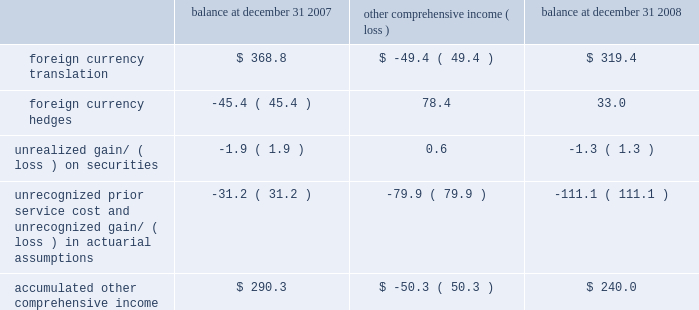The years ended december 31 , 2008 , 2007 and 2006 , due to ineffectiveness and amounts excluded from the assessment of hedge effectiveness , was not significant .
For contracts outstanding at december 31 , 2008 , we have an obligation to purchase u.s .
Dollars and sell euros , japanese yen , british pounds , canadian dollars , australian dollars and korean won and purchase swiss francs and sell u.s .
Dollars at set maturity dates ranging from january 2009 through june 2011 .
The notional amounts of outstanding forward contracts entered into with third parties to purchase u.s .
Dollars at december 31 , 2008 were $ 1343.0 million .
The notional amounts of outstanding forward contracts entered into with third parties to purchase swiss francs at december 31 , 2008 were $ 207.5 million .
The fair value of outstanding derivative instruments recorded on the balance sheet at december 31 , 2008 , together with settled derivatives where the hedged item has not yet affected earnings , was a net unrealized gain of $ 32.7 million , or $ 33.0 million net of taxes , which is deferred in other comprehensive income , of which $ 16.4 million , or $ 17.9 million , net of taxes , is expected to be reclassified to earnings over the next twelve months .
We also enter into foreign currency forward exchange contracts with terms of one month to manage currency exposures for assets and liabilities denominated in a currency other than an entity 2019s functional currency .
As a result , any foreign currency remeasurement gains/losses recognized in earnings under sfas no .
52 , 201cforeign currency translation , 201d are generally offset with gains/losses on the foreign currency forward exchange contracts in the same reporting period .
Other comprehensive income 2013 other comprehensive income refers to revenues , expenses , gains and losses that under generally accepted accounting principles are included in comprehensive income but are excluded from net earnings as these amounts are recorded directly as an adjustment to stockholders 2019 equity .
Other comprehensive income is comprised of foreign currency translation adjustments , unrealized foreign currency hedge gains and losses , unrealized gains and losses on available-for-sale securities and amortization of prior service costs and unrecognized gains and losses in actuarial assumptions .
In 2006 we adopted sfas 158 , 201cemployers 2019 accounting for defined benefit pension and other postretirement plans 2013 an amendment of fasb statements no .
87 , 88 , 106 and 132 ( r ) . 201d this statement required recognition of the funded status of our benefit plans in the statement of financial position and recognition of certain deferred gains or losses in other comprehensive income .
We recorded an unrealized loss of $ 35.4 million in other comprehensive income during 2006 related to the adoption of sfas 158 .
The components of accumulated other comprehensive income are as follows ( in millions ) : balance at december 31 , comprehensive income ( loss ) balance at december 31 .
During 2008 , we reclassified an investment previously accounted for under the equity method to an available-for-sale investment as we no longer exercised significant influence over the third-party investee .
The investment was marked-to- market in accordance with sfas 115 , 201caccounting for certain investments in debt and equity securities , 201d resulting in a net unrealized gain of $ 23.8 million recorded in other comprehensive income for 2008 .
This unrealized gain was reclassified to the income statement when we sold this investment in 2008 for total proceeds of $ 54.9 million and a gross realized gain of $ 38.8 million included in interest and other income .
The basis of these securities was determined based on the consideration paid at the time of acquisition .
Treasury stock 2013 we account for repurchases of common stock under the cost method and present treasury stock as a reduction of shareholders equity .
We may reissue common stock held in treasury only for limited purposes .
Accounting pronouncements 2013 in september 2006 , the fasb issued sfas no .
157 , 201cfair value measurements , 201d which defines fair value , establishes a framework for measuring fair value in generally accepted accounting principles and expands disclosures about fair value measurements .
This statement does not require any new fair value measurements , but provides guidance on how to measure fair value by providing a fair value hierarchy used to classify the source of the information .
Sfas no .
157 is effective for financial statements issued for fiscal years beginning after november 15 , 2007 and interim periods within those fiscal years .
In february 2008 , the fasb issued fasb staff position ( fsp ) no .
Sfas 157-2 , which delays the effective date of certain provisions of sfas no .
157 relating to non-financial assets and liabilities measured at fair value on a non-recurring basis until fiscal years beginning after november 15 , 2008 .
The full adoption of sfas no .
157 is not expected to have a material impact on our consolidated financial statements or results of operations .
Z i m m e r h o l d i n g s , i n c .
2 0 0 8 f o r m 1 0 - k a n n u a l r e p o r t notes to consolidated financial statements ( continued ) %%transmsg*** transmitting job : c48761 pcn : 046000000 ***%%pcmsg|46 |00009|yes|no|02/24/2009 19:24|0|0|page is valid , no graphics -- color : d| .
What percent higher would accumulated other comprehensive income be without unrecognized losses/costs? 
Computations: (((111.1 + 240.0) / 240.0) - 1)
Answer: 0.46292. 